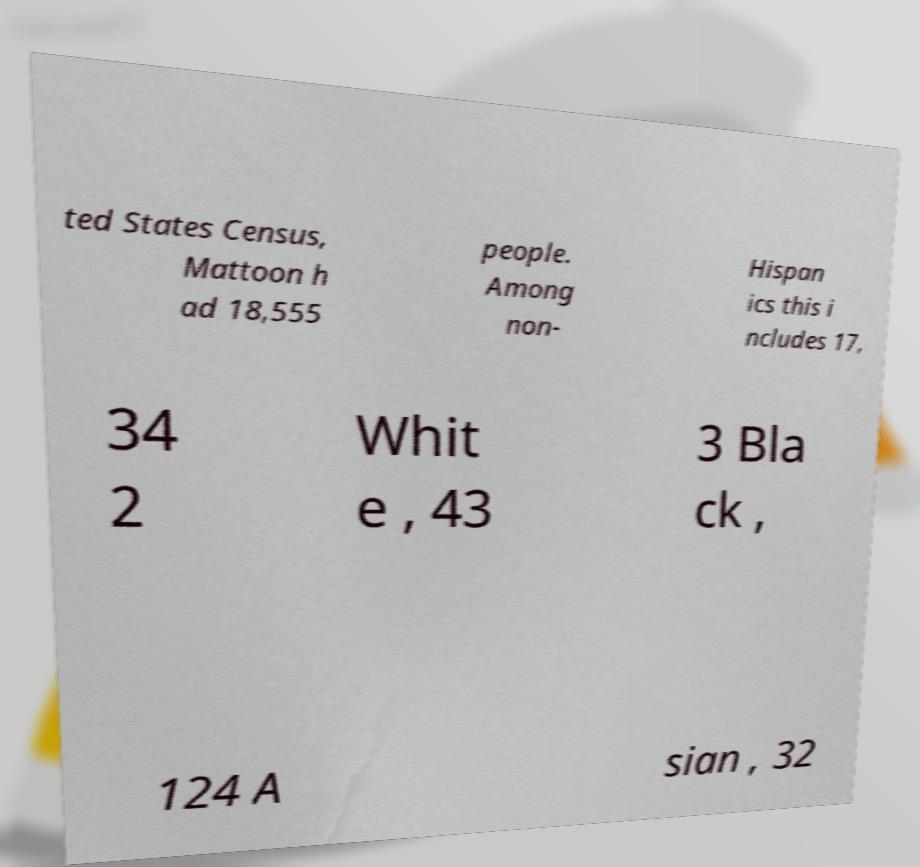Could you assist in decoding the text presented in this image and type it out clearly? ted States Census, Mattoon h ad 18,555 people. Among non- Hispan ics this i ncludes 17, 34 2 Whit e , 43 3 Bla ck , 124 A sian , 32 